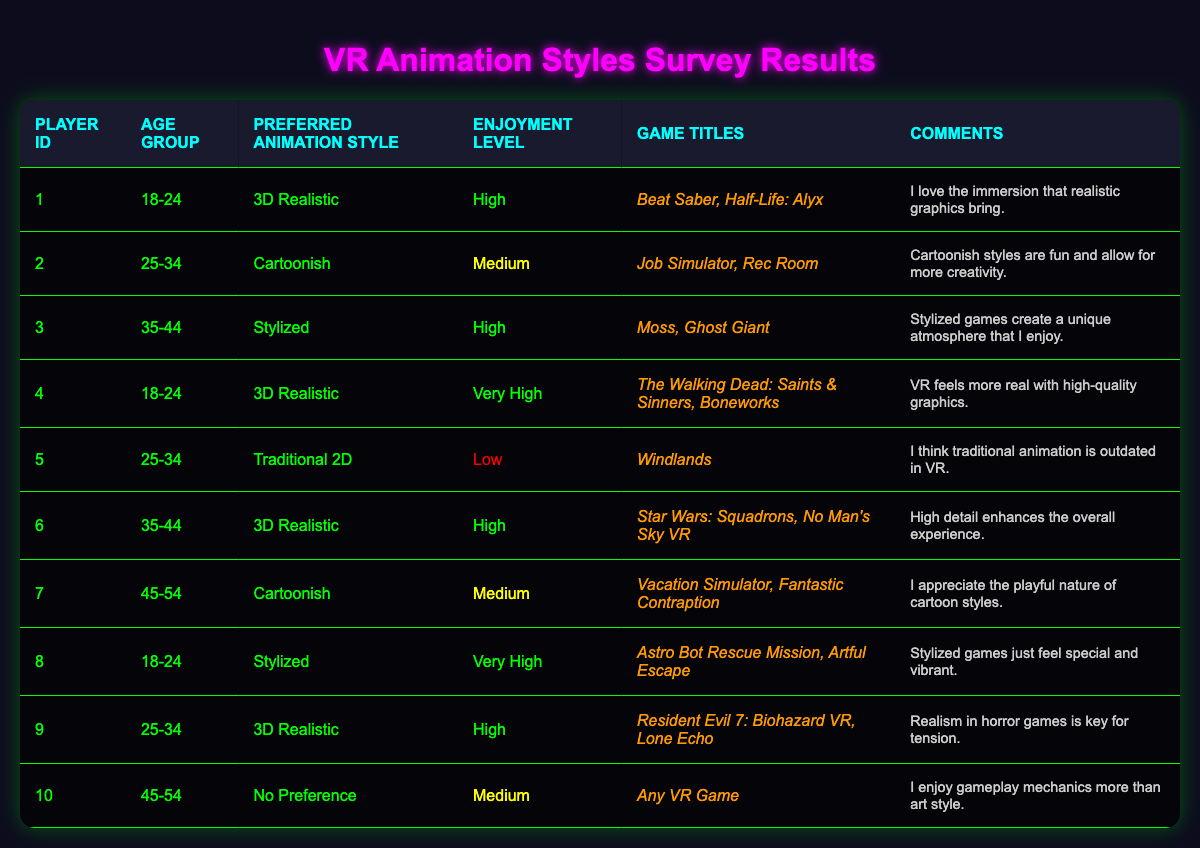What is the most preferred animation style among players aged 18-24? From the table, there are three players in the age group 18-24. Player 1 and Player 4 prefer "3D Realistic," while Player 8 prefers "Stylized." Since both Player 1 and Player 4 chose "3D Realistic," this is the most preferred style for this age group.
Answer: 3D Realistic How many players rated their enjoyment level as "Very High"? By examining the enjoyment levels in the table, Player 4 and Player 8 rated their enjoyment as "Very High." So, we count 2 players with that rating.
Answer: 2 What percentage of players in the survey prefer "Cartoonish" animation style? There are 10 players in total, and 3 players (Player 2, Player 7) prefer "Cartoonish." To find the percentage, we take (3/10) * 100, which equals 30%.
Answer: 30% Is there a player who prefers "Traditional 2D"? Reviewing Player 5, they prefer "Traditional 2D." Therefore, the answer to the question is yes.
Answer: Yes Which animation style has the highest enjoyment rating among those who prefer it? Players who rated their enjoyment as "Very High" include Player 4 and Player 8, both of whom preferred "3D Realistic" and "Stylized," respectively. The enjoyment levels ranked highest as "Very High," so both styles can be mentioned as having the highest rating.
Answer: 3D Realistic and Stylized What is the average enjoyment level for players who prefer "3D Realistic"? There are 5 players (Player 1, Player 4, Player 6, Player 9) who prefer "3D Realistic" with enjoyment levels of High (3 times), Very High (once), giving a weighted score of 4 High, and 1 Very High. We can assign values: Low=1, Medium=2, High=3, Very High=4. The sum is (3×3 + 4) = 13; so the average is 13/5 = 2.6, approximating to Medium.
Answer: Medium How many players aged 35-44 prefer a "Stylized" animation style? In the table, Player 3 (who is 35-44) prefers "Stylized." Thus, there is only one player in this age group that prefers this style.
Answer: 1 List all game titles associated with players who enjoy "High" levels of enjoyment. Players with "High" enjoyment levels include Player 1, Player 3, Player 4, Player 6, and Player 9. The associated game titles are "Beat Saber," "Half-Life: Alyx," "Moss," "Ghost Giant," "The Walking Dead: Saints & Sinners," "Boneworks," "Star Wars: Squadrons," "No Man's Sky VR," "Resident Evil 7: Biohazard VR," and "Lone Echo," resulting in a total of 10 titles.
Answer: 10 titles What is the most common game title played among players who prefer "Cartoonish" animation? Players who prefer "Cartoonish" animation (Player 2 and Player 7) played "Job Simulator," "Rec Room," "Vacation Simulator," and "Fantastic Contraption." None of these game titles overlap; therefore, there is no single common title among them.
Answer: No common title 